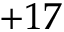<formula> <loc_0><loc_0><loc_500><loc_500>+ 1 7</formula> 